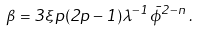<formula> <loc_0><loc_0><loc_500><loc_500>\beta = 3 \xi p ( 2 p - 1 ) \lambda ^ { - 1 } { \bar { \phi } } ^ { 2 - n } \, .</formula> 